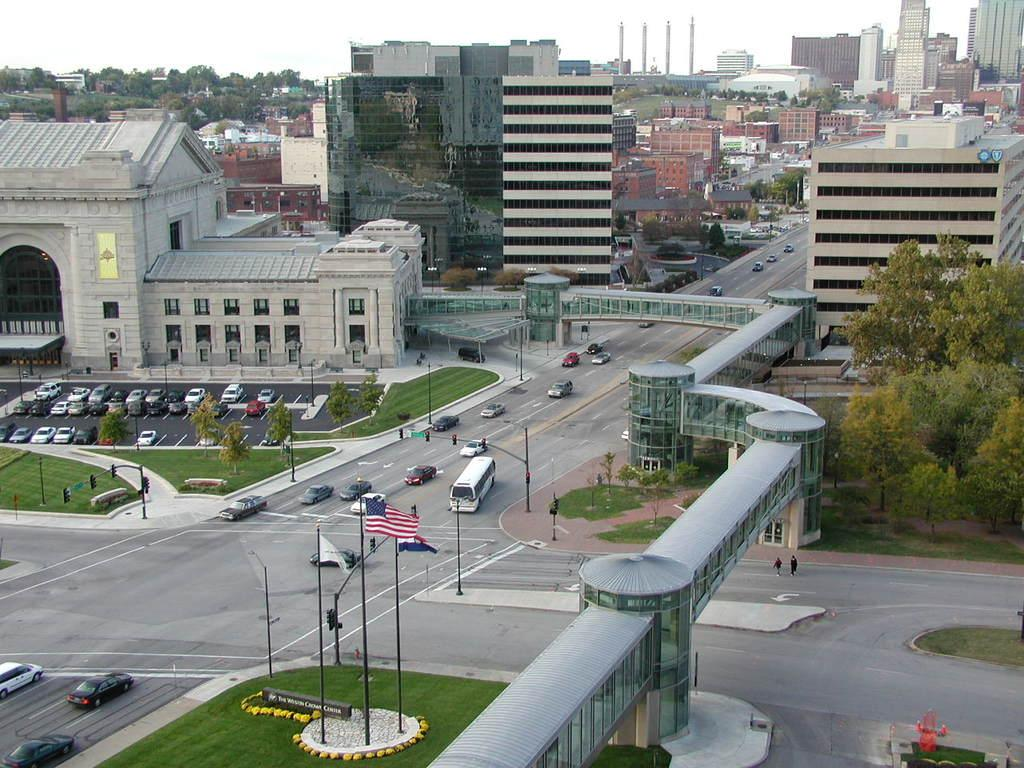What type of structures can be seen in the image? There are many buildings in the image. What natural elements are present in the image? There are trees and grass in the image. What type of transportation can be seen in the image? Vehicles are present on the road in the image. What type of fog can be seen surrounding the buildings in the image? There is no fog present in the image; the buildings and other elements are clearly visible. 